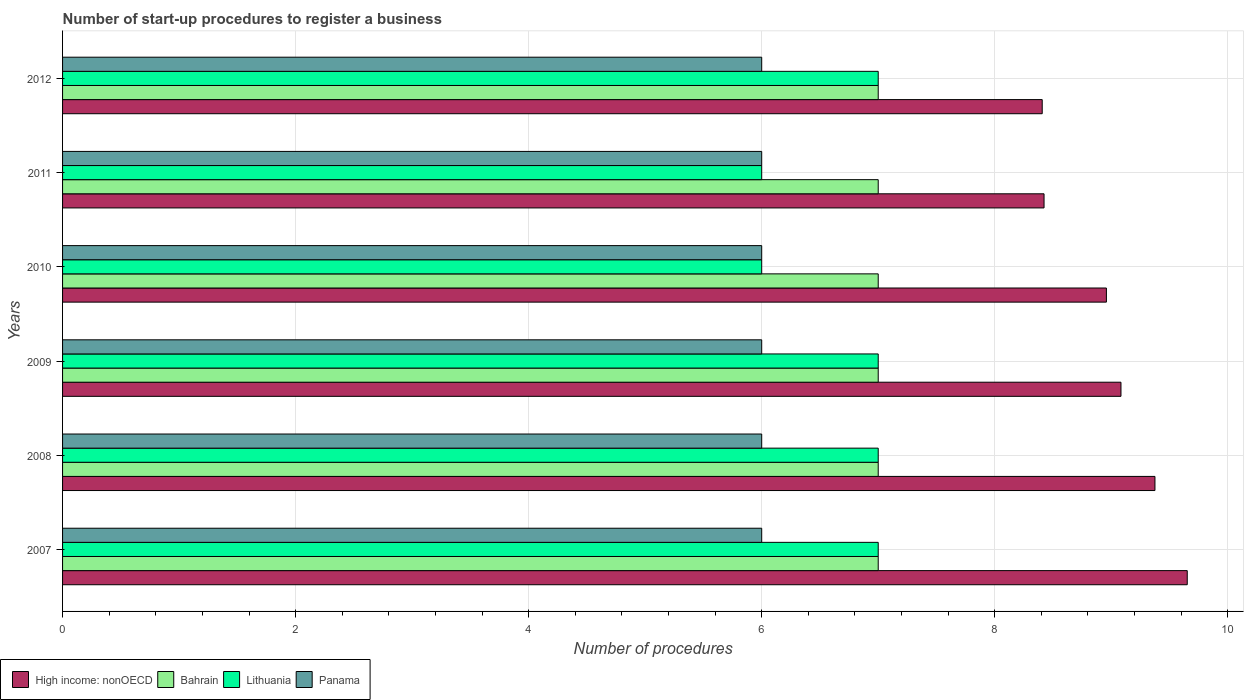How many bars are there on the 3rd tick from the top?
Your answer should be very brief. 4. In how many cases, is the number of bars for a given year not equal to the number of legend labels?
Your answer should be very brief. 0. Across all years, what is the maximum number of procedures required to register a business in Lithuania?
Offer a terse response. 7. Across all years, what is the minimum number of procedures required to register a business in Panama?
Offer a very short reply. 6. In which year was the number of procedures required to register a business in Lithuania maximum?
Give a very brief answer. 2007. What is the total number of procedures required to register a business in Panama in the graph?
Offer a terse response. 36. What is the difference between the number of procedures required to register a business in High income: nonOECD in 2010 and the number of procedures required to register a business in Lithuania in 2008?
Your answer should be very brief. 1.96. In the year 2011, what is the difference between the number of procedures required to register a business in High income: nonOECD and number of procedures required to register a business in Lithuania?
Provide a short and direct response. 2.42. In how many years, is the number of procedures required to register a business in Panama greater than 9.2 ?
Ensure brevity in your answer.  0. What is the ratio of the number of procedures required to register a business in Lithuania in 2009 to that in 2011?
Provide a short and direct response. 1.17. Is the number of procedures required to register a business in High income: nonOECD in 2007 less than that in 2011?
Give a very brief answer. No. Is the difference between the number of procedures required to register a business in High income: nonOECD in 2008 and 2010 greater than the difference between the number of procedures required to register a business in Lithuania in 2008 and 2010?
Give a very brief answer. No. What is the difference between the highest and the second highest number of procedures required to register a business in Lithuania?
Your answer should be compact. 0. What is the difference between the highest and the lowest number of procedures required to register a business in Lithuania?
Your answer should be compact. 1. Is the sum of the number of procedures required to register a business in Bahrain in 2010 and 2012 greater than the maximum number of procedures required to register a business in High income: nonOECD across all years?
Provide a short and direct response. Yes. Is it the case that in every year, the sum of the number of procedures required to register a business in Bahrain and number of procedures required to register a business in High income: nonOECD is greater than the sum of number of procedures required to register a business in Panama and number of procedures required to register a business in Lithuania?
Provide a short and direct response. Yes. What does the 3rd bar from the top in 2011 represents?
Provide a succinct answer. Bahrain. What does the 4th bar from the bottom in 2010 represents?
Your response must be concise. Panama. Is it the case that in every year, the sum of the number of procedures required to register a business in Bahrain and number of procedures required to register a business in Panama is greater than the number of procedures required to register a business in Lithuania?
Give a very brief answer. Yes. How many years are there in the graph?
Your answer should be very brief. 6. Does the graph contain any zero values?
Your answer should be compact. No. Does the graph contain grids?
Keep it short and to the point. Yes. Where does the legend appear in the graph?
Keep it short and to the point. Bottom left. What is the title of the graph?
Ensure brevity in your answer.  Number of start-up procedures to register a business. Does "Sint Maarten (Dutch part)" appear as one of the legend labels in the graph?
Provide a succinct answer. No. What is the label or title of the X-axis?
Your response must be concise. Number of procedures. What is the label or title of the Y-axis?
Your response must be concise. Years. What is the Number of procedures in High income: nonOECD in 2007?
Provide a succinct answer. 9.65. What is the Number of procedures in Lithuania in 2007?
Offer a very short reply. 7. What is the Number of procedures of High income: nonOECD in 2008?
Keep it short and to the point. 9.38. What is the Number of procedures of High income: nonOECD in 2009?
Make the answer very short. 9.08. What is the Number of procedures of Bahrain in 2009?
Offer a very short reply. 7. What is the Number of procedures of Lithuania in 2009?
Offer a very short reply. 7. What is the Number of procedures of High income: nonOECD in 2010?
Offer a terse response. 8.96. What is the Number of procedures of High income: nonOECD in 2011?
Provide a short and direct response. 8.42. What is the Number of procedures of Lithuania in 2011?
Provide a short and direct response. 6. What is the Number of procedures of High income: nonOECD in 2012?
Your answer should be compact. 8.41. Across all years, what is the maximum Number of procedures of High income: nonOECD?
Your answer should be very brief. 9.65. Across all years, what is the maximum Number of procedures in Bahrain?
Provide a succinct answer. 7. Across all years, what is the minimum Number of procedures in High income: nonOECD?
Make the answer very short. 8.41. What is the total Number of procedures in High income: nonOECD in the graph?
Offer a terse response. 53.9. What is the total Number of procedures in Bahrain in the graph?
Ensure brevity in your answer.  42. What is the total Number of procedures in Lithuania in the graph?
Provide a succinct answer. 40. What is the difference between the Number of procedures of High income: nonOECD in 2007 and that in 2008?
Your answer should be compact. 0.28. What is the difference between the Number of procedures of Bahrain in 2007 and that in 2008?
Your response must be concise. 0. What is the difference between the Number of procedures in Lithuania in 2007 and that in 2008?
Give a very brief answer. 0. What is the difference between the Number of procedures in High income: nonOECD in 2007 and that in 2009?
Offer a very short reply. 0.57. What is the difference between the Number of procedures of Bahrain in 2007 and that in 2009?
Keep it short and to the point. 0. What is the difference between the Number of procedures of Lithuania in 2007 and that in 2009?
Offer a very short reply. 0. What is the difference between the Number of procedures in Panama in 2007 and that in 2009?
Provide a succinct answer. 0. What is the difference between the Number of procedures in High income: nonOECD in 2007 and that in 2010?
Your answer should be very brief. 0.69. What is the difference between the Number of procedures of Bahrain in 2007 and that in 2010?
Offer a terse response. 0. What is the difference between the Number of procedures in Panama in 2007 and that in 2010?
Provide a succinct answer. 0. What is the difference between the Number of procedures of High income: nonOECD in 2007 and that in 2011?
Make the answer very short. 1.23. What is the difference between the Number of procedures of Bahrain in 2007 and that in 2011?
Offer a terse response. 0. What is the difference between the Number of procedures in Panama in 2007 and that in 2011?
Provide a short and direct response. 0. What is the difference between the Number of procedures of High income: nonOECD in 2007 and that in 2012?
Your response must be concise. 1.24. What is the difference between the Number of procedures of Lithuania in 2007 and that in 2012?
Offer a very short reply. 0. What is the difference between the Number of procedures in Panama in 2007 and that in 2012?
Your answer should be compact. 0. What is the difference between the Number of procedures of High income: nonOECD in 2008 and that in 2009?
Offer a very short reply. 0.29. What is the difference between the Number of procedures of Bahrain in 2008 and that in 2009?
Give a very brief answer. 0. What is the difference between the Number of procedures of Lithuania in 2008 and that in 2009?
Give a very brief answer. 0. What is the difference between the Number of procedures in Panama in 2008 and that in 2009?
Provide a short and direct response. 0. What is the difference between the Number of procedures in High income: nonOECD in 2008 and that in 2010?
Give a very brief answer. 0.42. What is the difference between the Number of procedures of Lithuania in 2008 and that in 2010?
Ensure brevity in your answer.  1. What is the difference between the Number of procedures of Panama in 2008 and that in 2010?
Your response must be concise. 0. What is the difference between the Number of procedures of High income: nonOECD in 2008 and that in 2011?
Provide a succinct answer. 0.95. What is the difference between the Number of procedures of Panama in 2008 and that in 2011?
Your answer should be very brief. 0. What is the difference between the Number of procedures in High income: nonOECD in 2008 and that in 2012?
Provide a succinct answer. 0.97. What is the difference between the Number of procedures in Bahrain in 2008 and that in 2012?
Provide a short and direct response. 0. What is the difference between the Number of procedures in Panama in 2008 and that in 2012?
Offer a terse response. 0. What is the difference between the Number of procedures in High income: nonOECD in 2009 and that in 2010?
Offer a terse response. 0.12. What is the difference between the Number of procedures of Bahrain in 2009 and that in 2010?
Provide a succinct answer. 0. What is the difference between the Number of procedures in High income: nonOECD in 2009 and that in 2011?
Your answer should be compact. 0.66. What is the difference between the Number of procedures of Panama in 2009 and that in 2011?
Ensure brevity in your answer.  0. What is the difference between the Number of procedures in High income: nonOECD in 2009 and that in 2012?
Provide a succinct answer. 0.68. What is the difference between the Number of procedures of Lithuania in 2009 and that in 2012?
Your response must be concise. 0. What is the difference between the Number of procedures in High income: nonOECD in 2010 and that in 2011?
Offer a terse response. 0.54. What is the difference between the Number of procedures in High income: nonOECD in 2010 and that in 2012?
Provide a succinct answer. 0.55. What is the difference between the Number of procedures of Lithuania in 2010 and that in 2012?
Give a very brief answer. -1. What is the difference between the Number of procedures in Panama in 2010 and that in 2012?
Provide a succinct answer. 0. What is the difference between the Number of procedures of High income: nonOECD in 2011 and that in 2012?
Offer a very short reply. 0.02. What is the difference between the Number of procedures in Bahrain in 2011 and that in 2012?
Your answer should be very brief. 0. What is the difference between the Number of procedures in Lithuania in 2011 and that in 2012?
Offer a very short reply. -1. What is the difference between the Number of procedures in High income: nonOECD in 2007 and the Number of procedures in Bahrain in 2008?
Make the answer very short. 2.65. What is the difference between the Number of procedures in High income: nonOECD in 2007 and the Number of procedures in Lithuania in 2008?
Your answer should be very brief. 2.65. What is the difference between the Number of procedures in High income: nonOECD in 2007 and the Number of procedures in Panama in 2008?
Offer a very short reply. 3.65. What is the difference between the Number of procedures of Bahrain in 2007 and the Number of procedures of Lithuania in 2008?
Give a very brief answer. 0. What is the difference between the Number of procedures of Bahrain in 2007 and the Number of procedures of Panama in 2008?
Ensure brevity in your answer.  1. What is the difference between the Number of procedures of High income: nonOECD in 2007 and the Number of procedures of Bahrain in 2009?
Your answer should be compact. 2.65. What is the difference between the Number of procedures in High income: nonOECD in 2007 and the Number of procedures in Lithuania in 2009?
Give a very brief answer. 2.65. What is the difference between the Number of procedures in High income: nonOECD in 2007 and the Number of procedures in Panama in 2009?
Provide a succinct answer. 3.65. What is the difference between the Number of procedures of Bahrain in 2007 and the Number of procedures of Panama in 2009?
Your response must be concise. 1. What is the difference between the Number of procedures in Lithuania in 2007 and the Number of procedures in Panama in 2009?
Make the answer very short. 1. What is the difference between the Number of procedures in High income: nonOECD in 2007 and the Number of procedures in Bahrain in 2010?
Your answer should be very brief. 2.65. What is the difference between the Number of procedures of High income: nonOECD in 2007 and the Number of procedures of Lithuania in 2010?
Offer a very short reply. 3.65. What is the difference between the Number of procedures in High income: nonOECD in 2007 and the Number of procedures in Panama in 2010?
Give a very brief answer. 3.65. What is the difference between the Number of procedures in Bahrain in 2007 and the Number of procedures in Lithuania in 2010?
Your response must be concise. 1. What is the difference between the Number of procedures of High income: nonOECD in 2007 and the Number of procedures of Bahrain in 2011?
Offer a terse response. 2.65. What is the difference between the Number of procedures in High income: nonOECD in 2007 and the Number of procedures in Lithuania in 2011?
Offer a terse response. 3.65. What is the difference between the Number of procedures of High income: nonOECD in 2007 and the Number of procedures of Panama in 2011?
Provide a short and direct response. 3.65. What is the difference between the Number of procedures in Bahrain in 2007 and the Number of procedures in Lithuania in 2011?
Ensure brevity in your answer.  1. What is the difference between the Number of procedures of Lithuania in 2007 and the Number of procedures of Panama in 2011?
Keep it short and to the point. 1. What is the difference between the Number of procedures in High income: nonOECD in 2007 and the Number of procedures in Bahrain in 2012?
Provide a short and direct response. 2.65. What is the difference between the Number of procedures of High income: nonOECD in 2007 and the Number of procedures of Lithuania in 2012?
Provide a short and direct response. 2.65. What is the difference between the Number of procedures in High income: nonOECD in 2007 and the Number of procedures in Panama in 2012?
Ensure brevity in your answer.  3.65. What is the difference between the Number of procedures of Bahrain in 2007 and the Number of procedures of Lithuania in 2012?
Your response must be concise. 0. What is the difference between the Number of procedures in Bahrain in 2007 and the Number of procedures in Panama in 2012?
Provide a short and direct response. 1. What is the difference between the Number of procedures in High income: nonOECD in 2008 and the Number of procedures in Bahrain in 2009?
Offer a terse response. 2.38. What is the difference between the Number of procedures in High income: nonOECD in 2008 and the Number of procedures in Lithuania in 2009?
Provide a succinct answer. 2.38. What is the difference between the Number of procedures of High income: nonOECD in 2008 and the Number of procedures of Panama in 2009?
Ensure brevity in your answer.  3.38. What is the difference between the Number of procedures of Bahrain in 2008 and the Number of procedures of Lithuania in 2009?
Provide a succinct answer. 0. What is the difference between the Number of procedures in Bahrain in 2008 and the Number of procedures in Panama in 2009?
Provide a succinct answer. 1. What is the difference between the Number of procedures of High income: nonOECD in 2008 and the Number of procedures of Bahrain in 2010?
Ensure brevity in your answer.  2.38. What is the difference between the Number of procedures of High income: nonOECD in 2008 and the Number of procedures of Lithuania in 2010?
Your answer should be compact. 3.38. What is the difference between the Number of procedures in High income: nonOECD in 2008 and the Number of procedures in Panama in 2010?
Your answer should be very brief. 3.38. What is the difference between the Number of procedures of High income: nonOECD in 2008 and the Number of procedures of Bahrain in 2011?
Your response must be concise. 2.38. What is the difference between the Number of procedures of High income: nonOECD in 2008 and the Number of procedures of Lithuania in 2011?
Offer a very short reply. 3.38. What is the difference between the Number of procedures in High income: nonOECD in 2008 and the Number of procedures in Panama in 2011?
Provide a short and direct response. 3.38. What is the difference between the Number of procedures in Bahrain in 2008 and the Number of procedures in Lithuania in 2011?
Offer a very short reply. 1. What is the difference between the Number of procedures of Lithuania in 2008 and the Number of procedures of Panama in 2011?
Give a very brief answer. 1. What is the difference between the Number of procedures of High income: nonOECD in 2008 and the Number of procedures of Bahrain in 2012?
Give a very brief answer. 2.38. What is the difference between the Number of procedures in High income: nonOECD in 2008 and the Number of procedures in Lithuania in 2012?
Offer a terse response. 2.38. What is the difference between the Number of procedures of High income: nonOECD in 2008 and the Number of procedures of Panama in 2012?
Keep it short and to the point. 3.38. What is the difference between the Number of procedures of Bahrain in 2008 and the Number of procedures of Panama in 2012?
Give a very brief answer. 1. What is the difference between the Number of procedures of High income: nonOECD in 2009 and the Number of procedures of Bahrain in 2010?
Give a very brief answer. 2.08. What is the difference between the Number of procedures of High income: nonOECD in 2009 and the Number of procedures of Lithuania in 2010?
Offer a terse response. 3.08. What is the difference between the Number of procedures of High income: nonOECD in 2009 and the Number of procedures of Panama in 2010?
Ensure brevity in your answer.  3.08. What is the difference between the Number of procedures of Bahrain in 2009 and the Number of procedures of Panama in 2010?
Your answer should be very brief. 1. What is the difference between the Number of procedures in Lithuania in 2009 and the Number of procedures in Panama in 2010?
Offer a terse response. 1. What is the difference between the Number of procedures of High income: nonOECD in 2009 and the Number of procedures of Bahrain in 2011?
Make the answer very short. 2.08. What is the difference between the Number of procedures in High income: nonOECD in 2009 and the Number of procedures in Lithuania in 2011?
Your answer should be compact. 3.08. What is the difference between the Number of procedures of High income: nonOECD in 2009 and the Number of procedures of Panama in 2011?
Ensure brevity in your answer.  3.08. What is the difference between the Number of procedures in Lithuania in 2009 and the Number of procedures in Panama in 2011?
Provide a succinct answer. 1. What is the difference between the Number of procedures in High income: nonOECD in 2009 and the Number of procedures in Bahrain in 2012?
Keep it short and to the point. 2.08. What is the difference between the Number of procedures in High income: nonOECD in 2009 and the Number of procedures in Lithuania in 2012?
Offer a terse response. 2.08. What is the difference between the Number of procedures in High income: nonOECD in 2009 and the Number of procedures in Panama in 2012?
Keep it short and to the point. 3.08. What is the difference between the Number of procedures in High income: nonOECD in 2010 and the Number of procedures in Bahrain in 2011?
Offer a very short reply. 1.96. What is the difference between the Number of procedures of High income: nonOECD in 2010 and the Number of procedures of Lithuania in 2011?
Provide a succinct answer. 2.96. What is the difference between the Number of procedures of High income: nonOECD in 2010 and the Number of procedures of Panama in 2011?
Your response must be concise. 2.96. What is the difference between the Number of procedures in Bahrain in 2010 and the Number of procedures in Panama in 2011?
Provide a succinct answer. 1. What is the difference between the Number of procedures in High income: nonOECD in 2010 and the Number of procedures in Bahrain in 2012?
Provide a succinct answer. 1.96. What is the difference between the Number of procedures in High income: nonOECD in 2010 and the Number of procedures in Lithuania in 2012?
Provide a succinct answer. 1.96. What is the difference between the Number of procedures in High income: nonOECD in 2010 and the Number of procedures in Panama in 2012?
Your response must be concise. 2.96. What is the difference between the Number of procedures of Bahrain in 2010 and the Number of procedures of Panama in 2012?
Provide a succinct answer. 1. What is the difference between the Number of procedures in Lithuania in 2010 and the Number of procedures in Panama in 2012?
Provide a succinct answer. 0. What is the difference between the Number of procedures of High income: nonOECD in 2011 and the Number of procedures of Bahrain in 2012?
Ensure brevity in your answer.  1.42. What is the difference between the Number of procedures of High income: nonOECD in 2011 and the Number of procedures of Lithuania in 2012?
Your answer should be compact. 1.42. What is the difference between the Number of procedures of High income: nonOECD in 2011 and the Number of procedures of Panama in 2012?
Offer a very short reply. 2.42. What is the difference between the Number of procedures in Bahrain in 2011 and the Number of procedures in Panama in 2012?
Provide a succinct answer. 1. What is the difference between the Number of procedures of Lithuania in 2011 and the Number of procedures of Panama in 2012?
Offer a terse response. 0. What is the average Number of procedures in High income: nonOECD per year?
Provide a short and direct response. 8.98. What is the average Number of procedures of Bahrain per year?
Keep it short and to the point. 7. In the year 2007, what is the difference between the Number of procedures in High income: nonOECD and Number of procedures in Bahrain?
Make the answer very short. 2.65. In the year 2007, what is the difference between the Number of procedures in High income: nonOECD and Number of procedures in Lithuania?
Give a very brief answer. 2.65. In the year 2007, what is the difference between the Number of procedures of High income: nonOECD and Number of procedures of Panama?
Provide a short and direct response. 3.65. In the year 2007, what is the difference between the Number of procedures of Bahrain and Number of procedures of Lithuania?
Your answer should be very brief. 0. In the year 2007, what is the difference between the Number of procedures of Bahrain and Number of procedures of Panama?
Your answer should be compact. 1. In the year 2008, what is the difference between the Number of procedures of High income: nonOECD and Number of procedures of Bahrain?
Offer a terse response. 2.38. In the year 2008, what is the difference between the Number of procedures in High income: nonOECD and Number of procedures in Lithuania?
Make the answer very short. 2.38. In the year 2008, what is the difference between the Number of procedures of High income: nonOECD and Number of procedures of Panama?
Your response must be concise. 3.38. In the year 2008, what is the difference between the Number of procedures of Bahrain and Number of procedures of Lithuania?
Your response must be concise. 0. In the year 2008, what is the difference between the Number of procedures in Bahrain and Number of procedures in Panama?
Make the answer very short. 1. In the year 2009, what is the difference between the Number of procedures of High income: nonOECD and Number of procedures of Bahrain?
Keep it short and to the point. 2.08. In the year 2009, what is the difference between the Number of procedures of High income: nonOECD and Number of procedures of Lithuania?
Offer a very short reply. 2.08. In the year 2009, what is the difference between the Number of procedures in High income: nonOECD and Number of procedures in Panama?
Your response must be concise. 3.08. In the year 2010, what is the difference between the Number of procedures of High income: nonOECD and Number of procedures of Bahrain?
Offer a terse response. 1.96. In the year 2010, what is the difference between the Number of procedures in High income: nonOECD and Number of procedures in Lithuania?
Keep it short and to the point. 2.96. In the year 2010, what is the difference between the Number of procedures in High income: nonOECD and Number of procedures in Panama?
Offer a very short reply. 2.96. In the year 2010, what is the difference between the Number of procedures of Bahrain and Number of procedures of Lithuania?
Keep it short and to the point. 1. In the year 2010, what is the difference between the Number of procedures in Lithuania and Number of procedures in Panama?
Keep it short and to the point. 0. In the year 2011, what is the difference between the Number of procedures of High income: nonOECD and Number of procedures of Bahrain?
Your response must be concise. 1.42. In the year 2011, what is the difference between the Number of procedures in High income: nonOECD and Number of procedures in Lithuania?
Provide a succinct answer. 2.42. In the year 2011, what is the difference between the Number of procedures in High income: nonOECD and Number of procedures in Panama?
Ensure brevity in your answer.  2.42. In the year 2011, what is the difference between the Number of procedures of Bahrain and Number of procedures of Lithuania?
Your answer should be compact. 1. In the year 2011, what is the difference between the Number of procedures of Bahrain and Number of procedures of Panama?
Your response must be concise. 1. In the year 2012, what is the difference between the Number of procedures of High income: nonOECD and Number of procedures of Bahrain?
Give a very brief answer. 1.41. In the year 2012, what is the difference between the Number of procedures of High income: nonOECD and Number of procedures of Lithuania?
Provide a succinct answer. 1.41. In the year 2012, what is the difference between the Number of procedures in High income: nonOECD and Number of procedures in Panama?
Provide a short and direct response. 2.41. In the year 2012, what is the difference between the Number of procedures in Bahrain and Number of procedures in Panama?
Make the answer very short. 1. What is the ratio of the Number of procedures of High income: nonOECD in 2007 to that in 2008?
Make the answer very short. 1.03. What is the ratio of the Number of procedures in Lithuania in 2007 to that in 2008?
Provide a succinct answer. 1. What is the ratio of the Number of procedures in Panama in 2007 to that in 2008?
Provide a succinct answer. 1. What is the ratio of the Number of procedures in High income: nonOECD in 2007 to that in 2009?
Provide a succinct answer. 1.06. What is the ratio of the Number of procedures of Bahrain in 2007 to that in 2009?
Your response must be concise. 1. What is the ratio of the Number of procedures in Lithuania in 2007 to that in 2009?
Offer a terse response. 1. What is the ratio of the Number of procedures in Panama in 2007 to that in 2009?
Your response must be concise. 1. What is the ratio of the Number of procedures in High income: nonOECD in 2007 to that in 2010?
Your answer should be compact. 1.08. What is the ratio of the Number of procedures of Lithuania in 2007 to that in 2010?
Provide a short and direct response. 1.17. What is the ratio of the Number of procedures of High income: nonOECD in 2007 to that in 2011?
Offer a very short reply. 1.15. What is the ratio of the Number of procedures of Bahrain in 2007 to that in 2011?
Keep it short and to the point. 1. What is the ratio of the Number of procedures in Lithuania in 2007 to that in 2011?
Your response must be concise. 1.17. What is the ratio of the Number of procedures in High income: nonOECD in 2007 to that in 2012?
Offer a terse response. 1.15. What is the ratio of the Number of procedures in Bahrain in 2007 to that in 2012?
Keep it short and to the point. 1. What is the ratio of the Number of procedures in Panama in 2007 to that in 2012?
Provide a succinct answer. 1. What is the ratio of the Number of procedures of High income: nonOECD in 2008 to that in 2009?
Ensure brevity in your answer.  1.03. What is the ratio of the Number of procedures in High income: nonOECD in 2008 to that in 2010?
Provide a succinct answer. 1.05. What is the ratio of the Number of procedures in Bahrain in 2008 to that in 2010?
Offer a very short reply. 1. What is the ratio of the Number of procedures in Lithuania in 2008 to that in 2010?
Ensure brevity in your answer.  1.17. What is the ratio of the Number of procedures of Panama in 2008 to that in 2010?
Make the answer very short. 1. What is the ratio of the Number of procedures of High income: nonOECD in 2008 to that in 2011?
Your response must be concise. 1.11. What is the ratio of the Number of procedures of Bahrain in 2008 to that in 2011?
Offer a terse response. 1. What is the ratio of the Number of procedures of Lithuania in 2008 to that in 2011?
Your answer should be very brief. 1.17. What is the ratio of the Number of procedures in Panama in 2008 to that in 2011?
Ensure brevity in your answer.  1. What is the ratio of the Number of procedures of High income: nonOECD in 2008 to that in 2012?
Your answer should be very brief. 1.12. What is the ratio of the Number of procedures of Lithuania in 2008 to that in 2012?
Provide a short and direct response. 1. What is the ratio of the Number of procedures of High income: nonOECD in 2009 to that in 2010?
Ensure brevity in your answer.  1.01. What is the ratio of the Number of procedures of High income: nonOECD in 2009 to that in 2011?
Provide a succinct answer. 1.08. What is the ratio of the Number of procedures in High income: nonOECD in 2009 to that in 2012?
Keep it short and to the point. 1.08. What is the ratio of the Number of procedures in Lithuania in 2009 to that in 2012?
Provide a succinct answer. 1. What is the ratio of the Number of procedures of High income: nonOECD in 2010 to that in 2011?
Your response must be concise. 1.06. What is the ratio of the Number of procedures in Bahrain in 2010 to that in 2011?
Your answer should be very brief. 1. What is the ratio of the Number of procedures in Lithuania in 2010 to that in 2011?
Offer a terse response. 1. What is the ratio of the Number of procedures in High income: nonOECD in 2010 to that in 2012?
Your response must be concise. 1.07. What is the ratio of the Number of procedures of Bahrain in 2010 to that in 2012?
Your answer should be very brief. 1. What is the ratio of the Number of procedures in Lithuania in 2011 to that in 2012?
Provide a short and direct response. 0.86. What is the ratio of the Number of procedures of Panama in 2011 to that in 2012?
Offer a very short reply. 1. What is the difference between the highest and the second highest Number of procedures in High income: nonOECD?
Make the answer very short. 0.28. What is the difference between the highest and the lowest Number of procedures in High income: nonOECD?
Give a very brief answer. 1.24. What is the difference between the highest and the lowest Number of procedures in Bahrain?
Make the answer very short. 0. What is the difference between the highest and the lowest Number of procedures of Lithuania?
Keep it short and to the point. 1. 